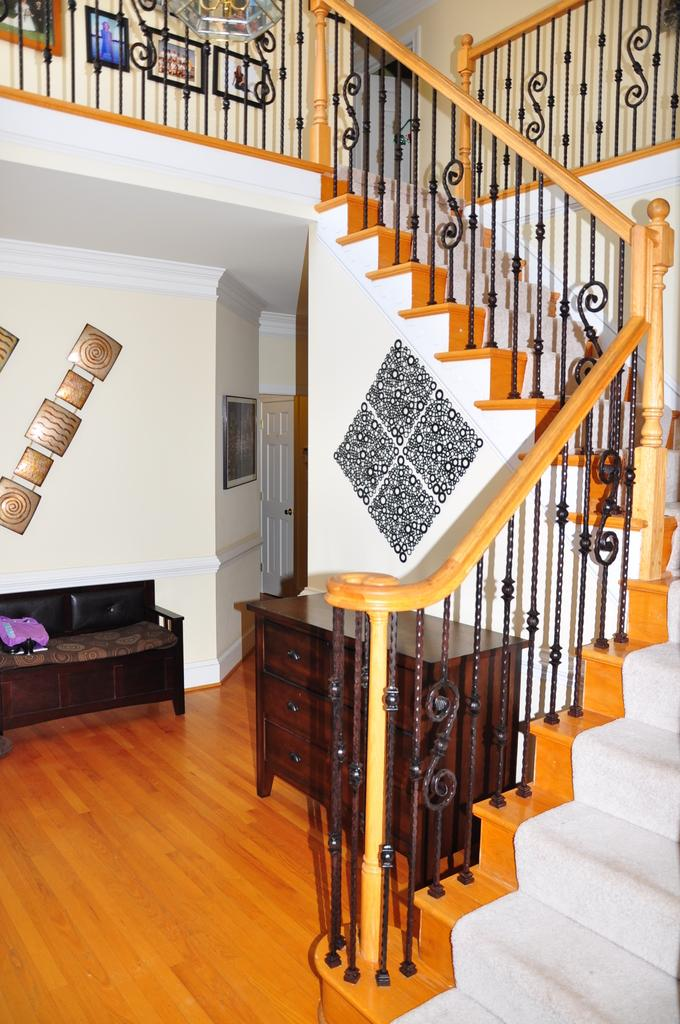What type of room is depicted in the image? There is a living room in the image. Are there any architectural features visible in the living room? Yes, there is a staircase in the image. What type of cake is being served on the plants in the image? There is no cake or plants present in the image. 